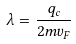Convert formula to latex. <formula><loc_0><loc_0><loc_500><loc_500>\lambda = \frac { q _ { c } } { 2 m v _ { F } }</formula> 